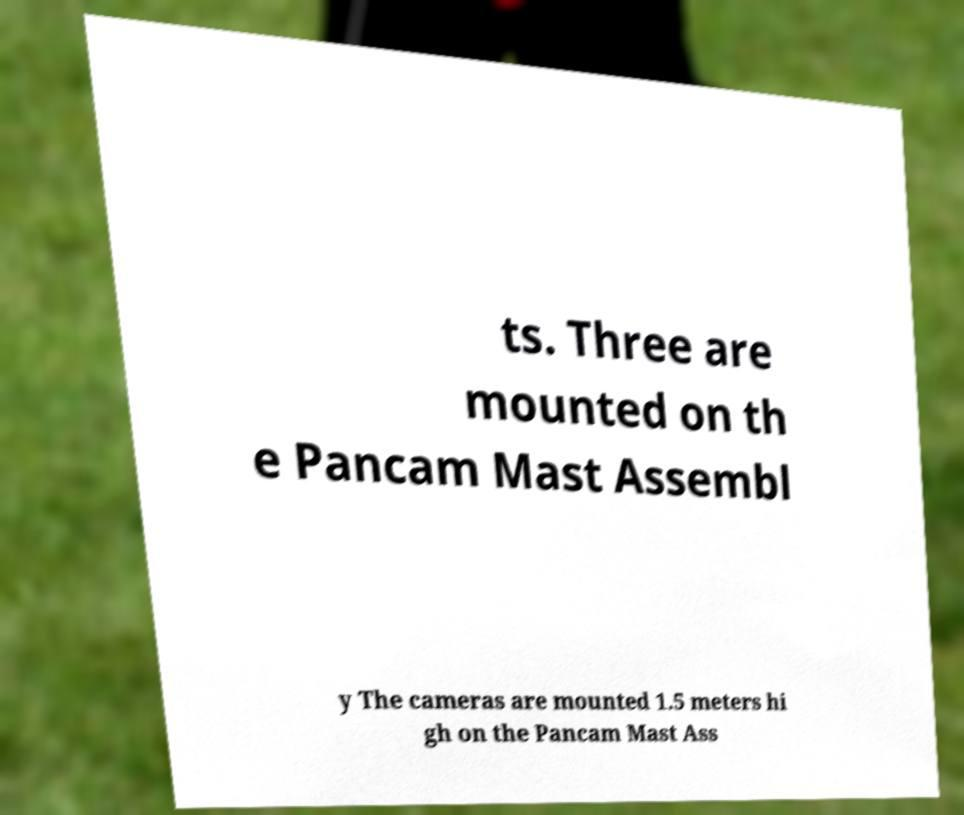Can you accurately transcribe the text from the provided image for me? ts. Three are mounted on th e Pancam Mast Assembl y The cameras are mounted 1.5 meters hi gh on the Pancam Mast Ass 